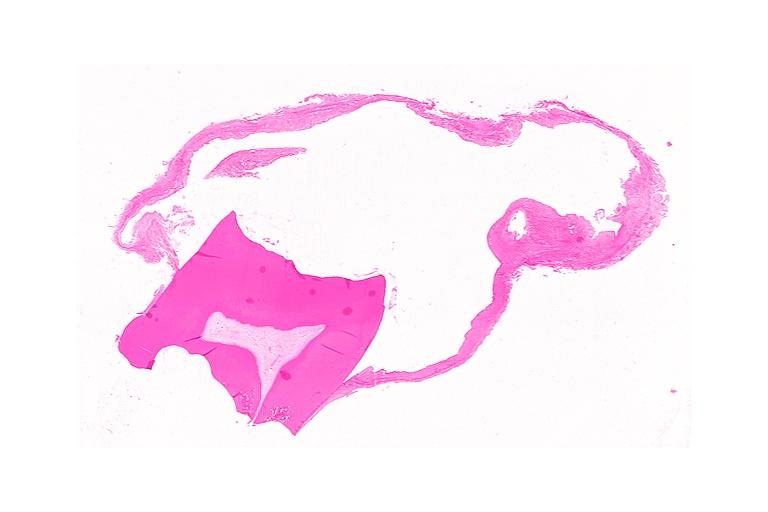s oral present?
Answer the question using a single word or phrase. Yes 